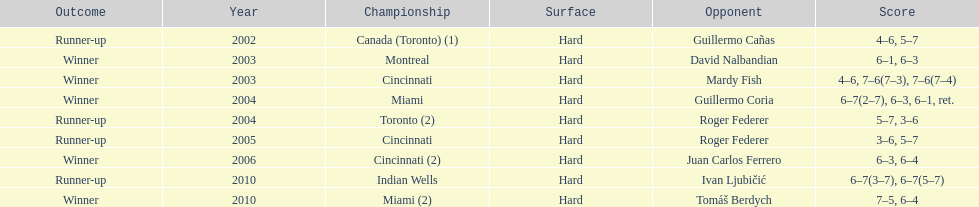On how many occasions has he been the runner-up? 4. 